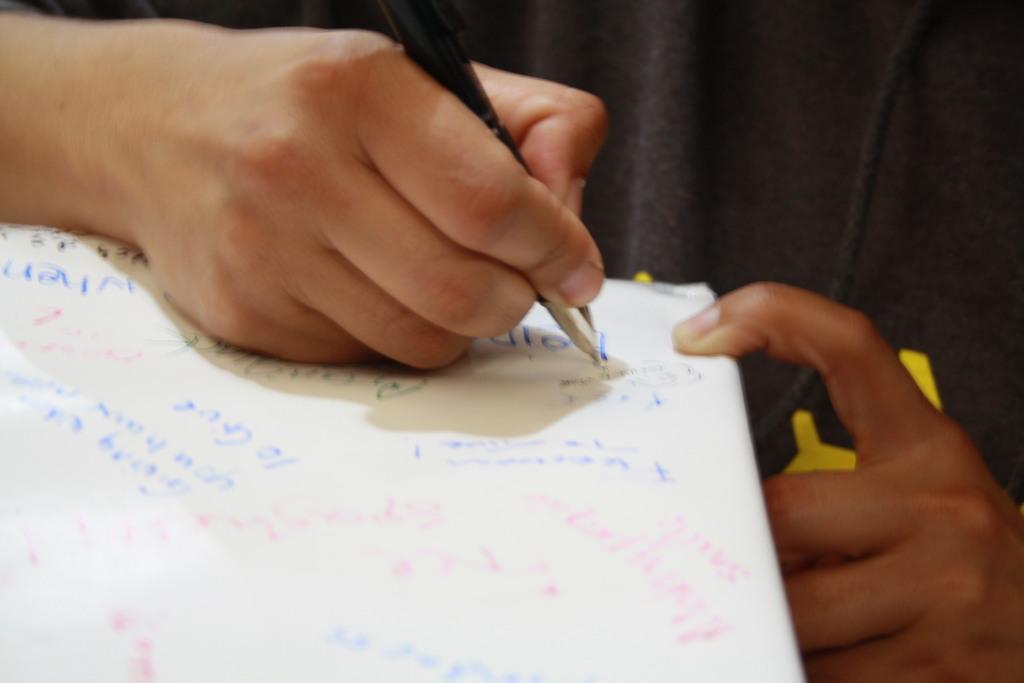How would you summarize this image in a sentence or two? In this picture, we see the hand of the human holding a black pen. He or she is writing something on the white paper. In the background, it is black in color. 